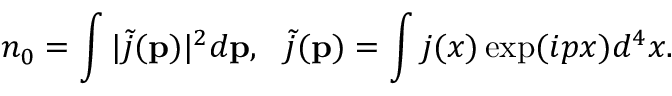<formula> <loc_0><loc_0><loc_500><loc_500>n _ { 0 } = \int | \tilde { j } ( { p } ) | ^ { 2 } d { p } , \tilde { j } ( { p } ) = \int j ( x ) \exp ( i p x ) d ^ { 4 } x .</formula> 